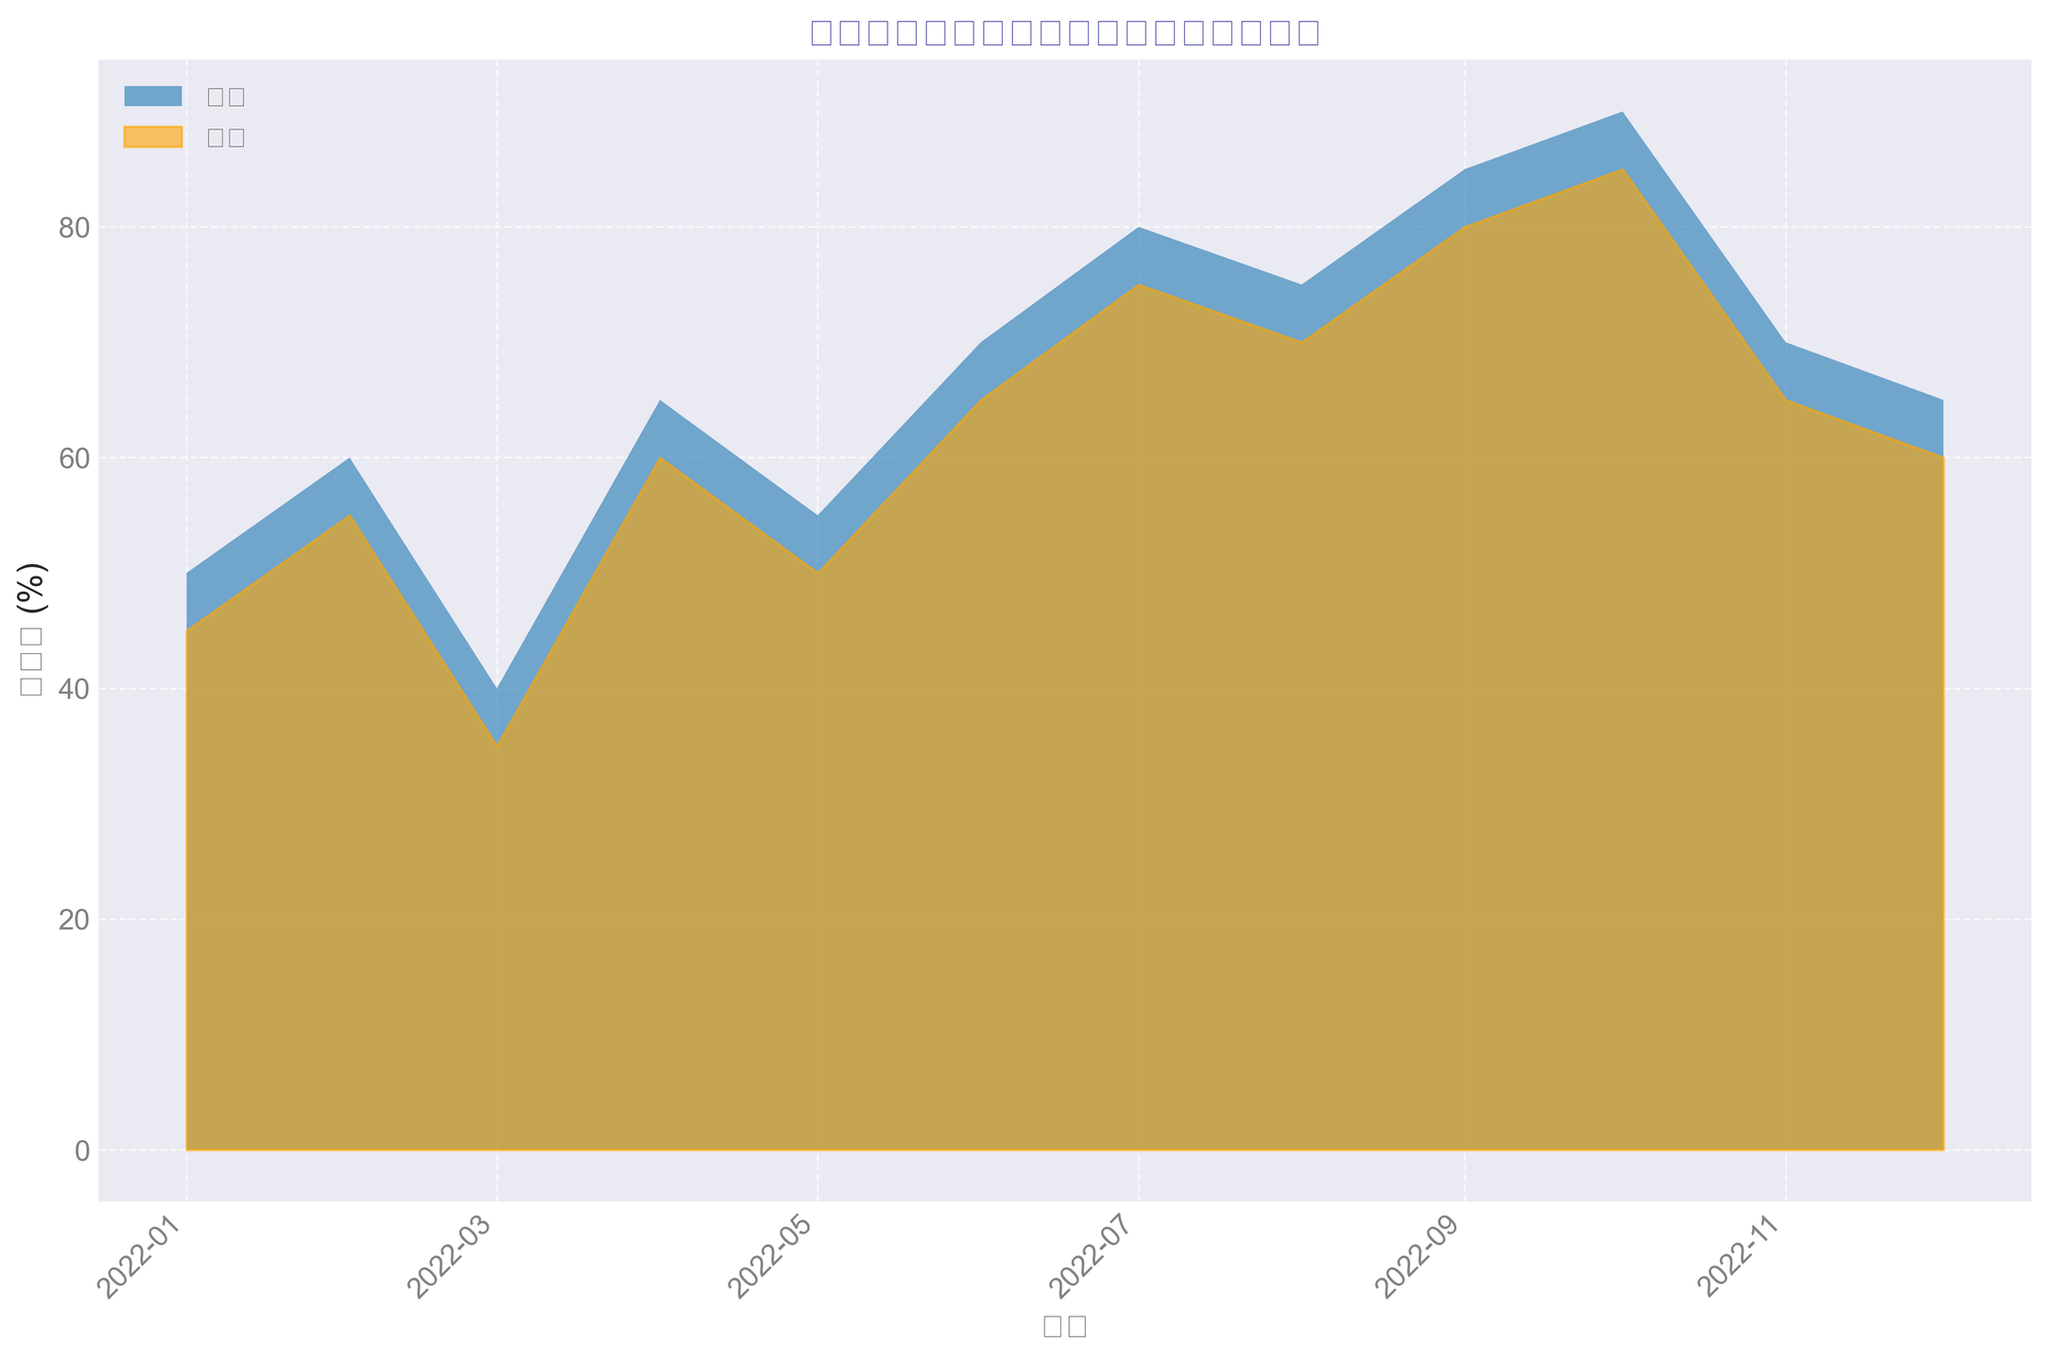在图表上显示的时间范围是什么？ 通过观察图表，可以看到X轴代表日期，从“2022-01”到“2022-12”
Answer: 2022年全年 哪个月份农村的文化活动参与率最高？ 观察农村地区的区域图，可以看到在2022年10月参与率最高
Answer: 2022年10月 农历新年期间（1月份）城市和农村的文化活动参与率分别是多少？ 查看图表在2022年1月的数值，城市为50%，农村为45%
Answer: 城市50%，农村45% 在2022年9月至10月期间，城市和农村的文化活动参与率增加了多少？ 城市从85%增加到90%，增加了5%；农村从80%增加到85%，增加了5%
Answer: 都是5% 两地中哪一个月的文化活动参与率差距最大？ 比较所有月份城市和农村的参与率差值，可以看到在2022年1月差距最大，差值为50%-45%=5%
Answer: 2022年1月 图表上显示的衡量标准是什么？ 通过图表Y轴标签，可以看到衡量标准是“参与率 (%)”
Answer: 参与率 (%) 今年10月份，城市和农村地区的文化活动参与率分别是多少？ 观察10月份的数据，城市为90%，农村为85%
Answer: 城市90%，农村85% 在2022年全年中，城市和农村地区的文化活动参与率趋势如何？ 城市和农村地区在全年中文化活动参与率逐渐上升，特别是在下半年达到高峰
Answer: 全年上涨 城市和农村的哪一个月份文化活动参与率都没有超过50%？ 查看图表上的数据，2022年3月份城市40%，农村35%
Answer: 2022年3月 为什么城市和农村的文化活动参与率在9月到10月之间都会有所提升？ 这是在国庆节期间，文化活动通常较多，导致参与率上升
Answer: 国庆节期间 城市和农村的文化活动参与率在年度最高月份分别是多少？ 观察图表年度峰值，城市为2022年10月90%，农村为2022年10月85%
Answer: 城市90%，农村85% 农村和城市在哪个月份的文化活动参与率最接近？ 观察各月份参与率，可以看到5月份，城市55%，农村50%，差距最小
Answer: 2022年5月 观察图表中，哪些月份的城市文化活动参与率超过了70%？ 通过图表看到，7月、8月、9月、10月份城市的参与率都超过了70%
Answer: 7月、8月、9月、10月 